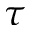<formula> <loc_0><loc_0><loc_500><loc_500>\tau</formula> 